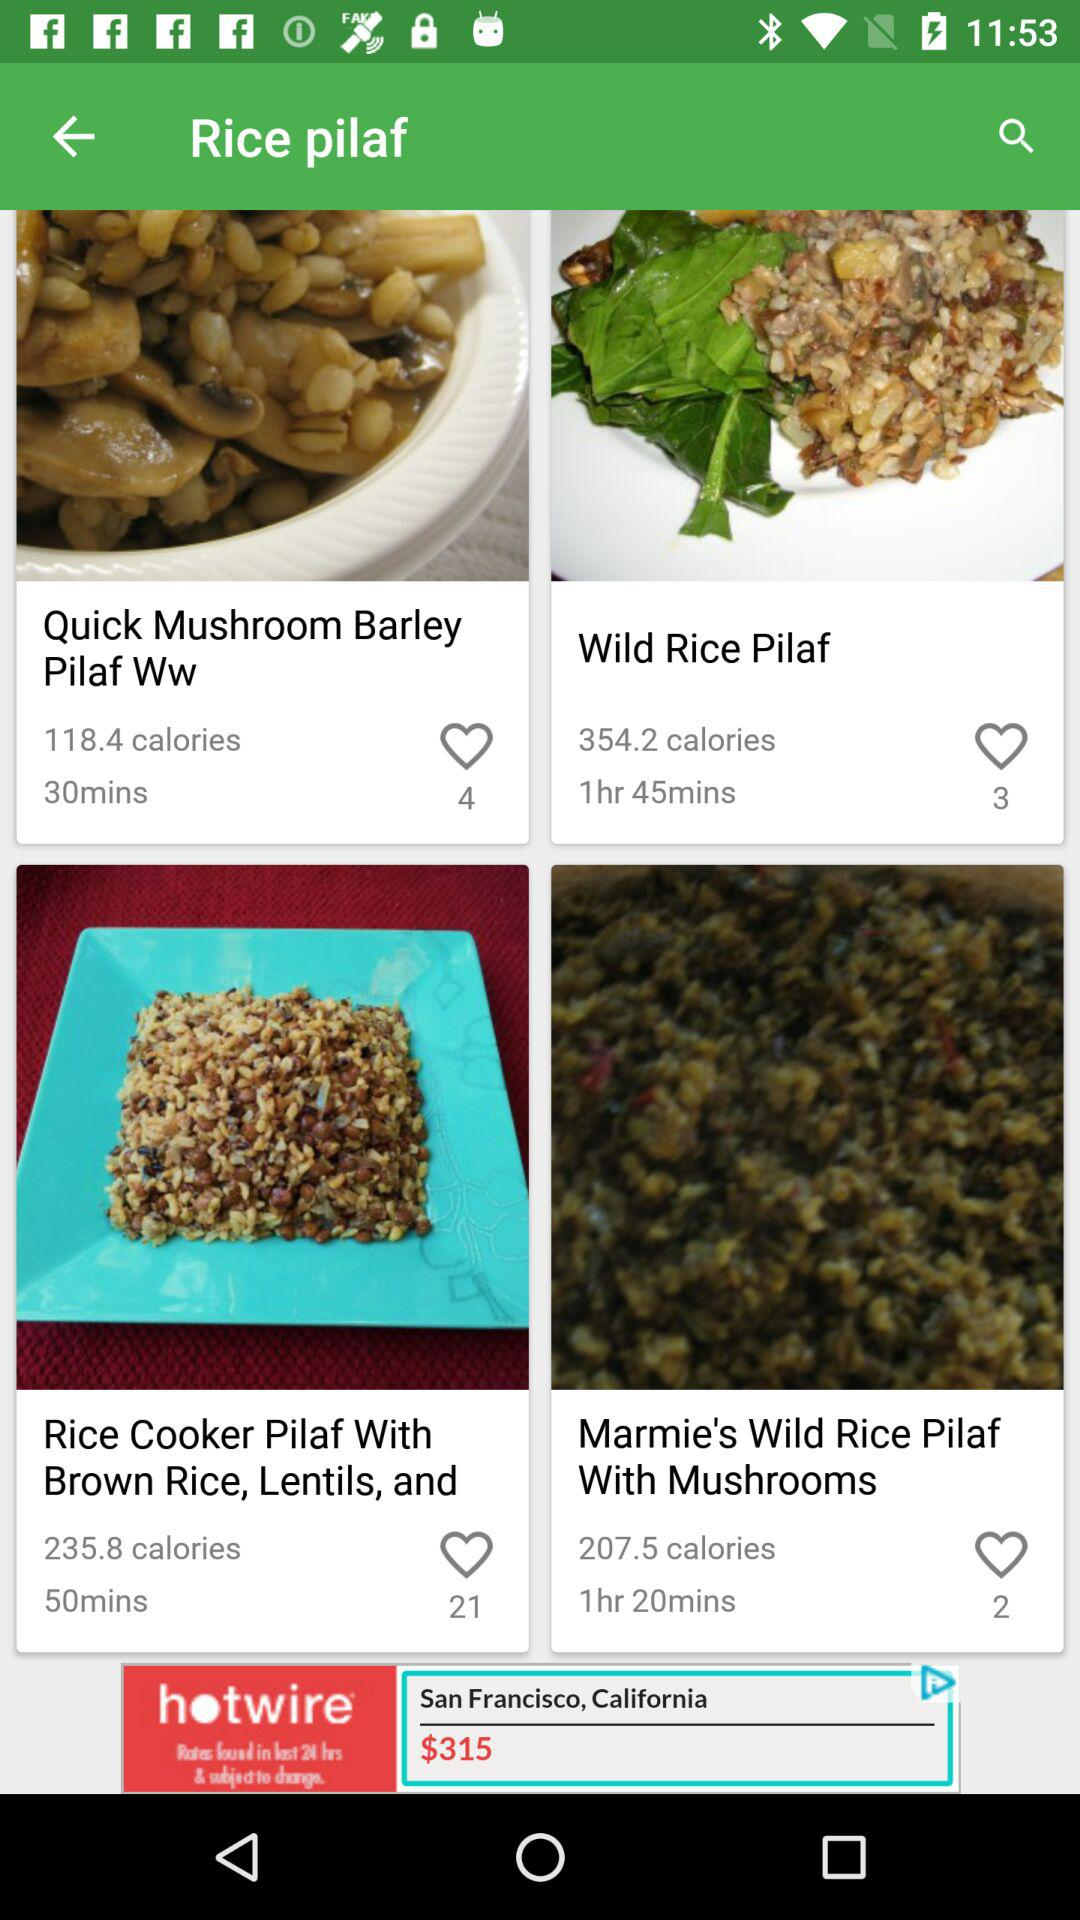How many likes are of "Rice Cooker Pilaf With Brown Rice, Lentils, and"? There are 21 likes. 